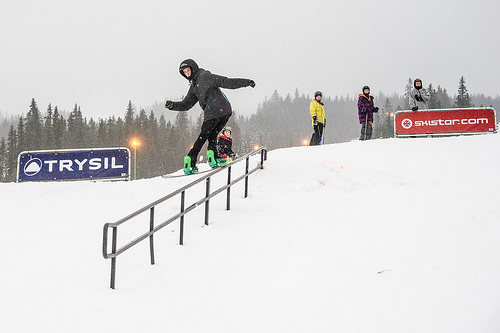What is the hill covered in? The hill is covered in a thick layer of pristine snow, creating a winter wonderland scene. 